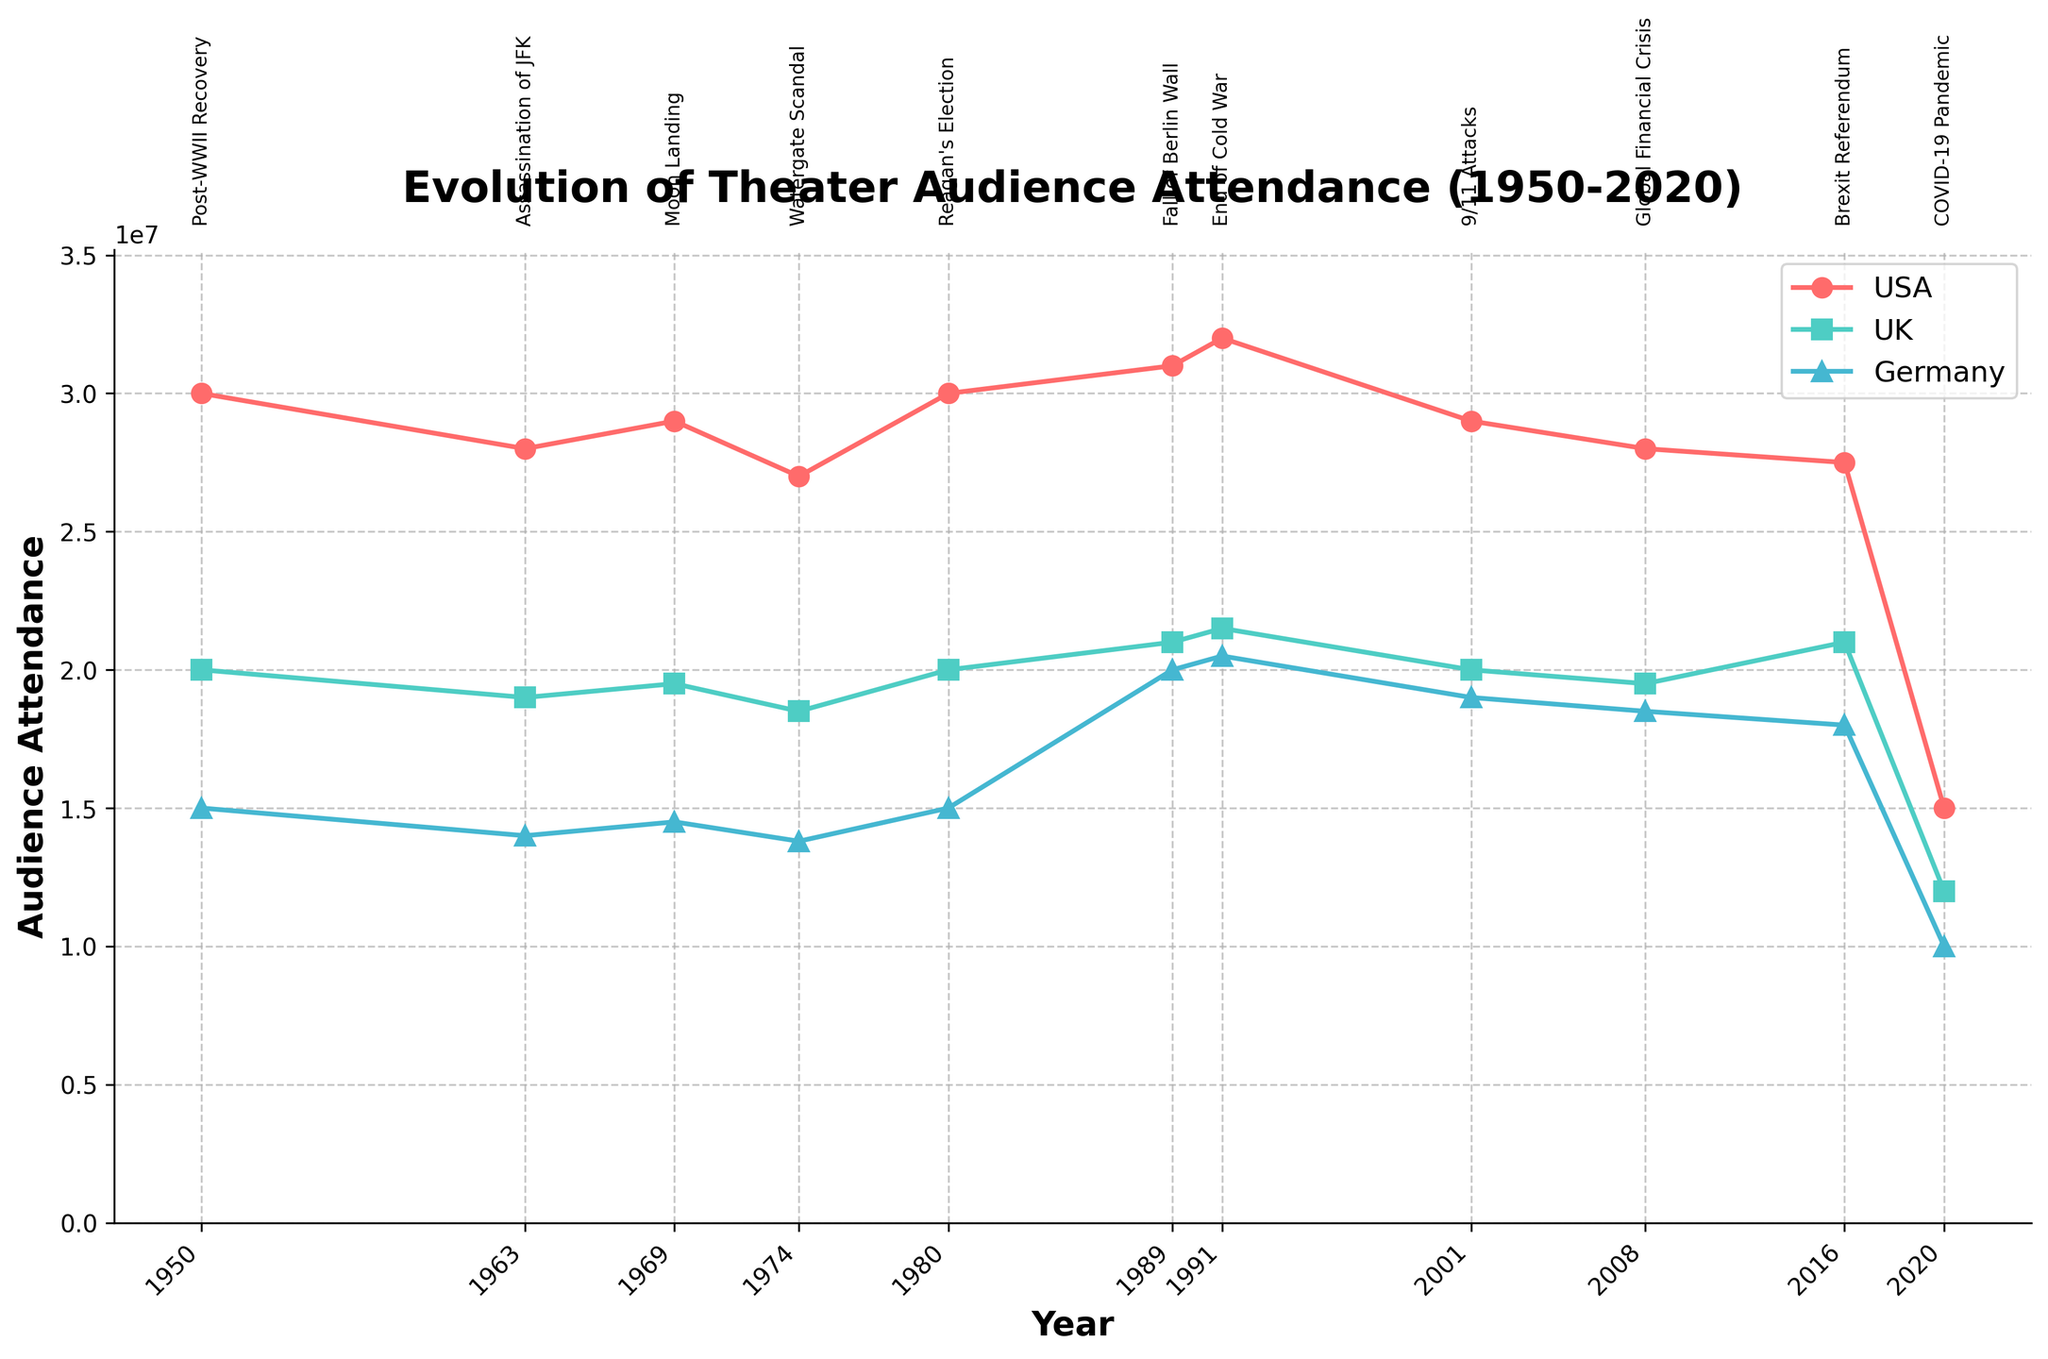What is the title of the plot? The title is located at the top of the figure and is usually bold and larger than other text elements.
Answer: Evolution of Theater Audience Attendance (1950-2020) Which country had the highest audience attendance in 1989? To find this, look at the data points for 1989 and compare the values for the USA, UK, and Germany. The highest one is the answer.
Answer: Germany During which years do all countries experience a significant decrease in audience attendance? Examine the trend lines for all three countries and identify the year(s) where all lines show a clear drop.
Answer: 2020 What was the approximate audience attendance in the UK during the Moon Landing in 1969? Find the data point for the UK in 1969 and note its position on the y-axis.
Answer: 19,500,000 How did audience attendance in Germany change between the Fall of Berlin Wall (1989) and the End of Cold War (1991)? Compare the audience attendance in Germany for 1989 and 1991. Subtract the 1989 value from the 1991 value.
Answer: Increased by 500,000 Which event is annotated closest to the middle of the time series? Review the annotations along the time axis and determine which event is closest to the mid-point of the timeline (approximately the year 1985).
Answer: Fall of Berlin Wall By what percentage did the audience attendance in the USA decrease from 2016 to 2020? Calculate the percentage decrease using the formula \(\frac{\text{initial value} - \text{final value}}{\text{initial value}} \times 100\) for the period from 2016 (27,500,000) to 2020 (15,000,000).
Answer: 45.45% Which country shows the highest variability in audience attendance over the entire period? Observe the fluctuations in the plot for each country. The country with the most pronounced ups and downs has the highest variability.
Answer: USA Are there any years where the audience attendance values for USA and UK are equal? Visually inspect the lines for USA and UK and see if they intersect at any year.
Answer: No What is the trend of audience attendance in the UK after the 9/11 Attacks in 2001? Note the trajectory of the UK's line from 2001 onward. Determine if it is rising, falling, or stable.
Answer: Generally falling 